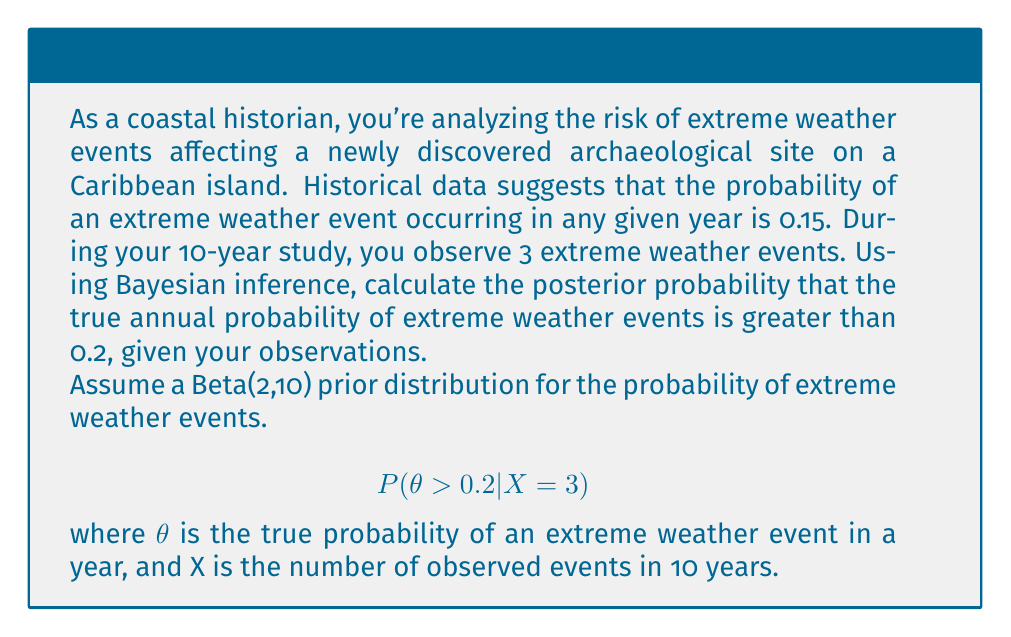What is the answer to this math problem? Let's approach this step-by-step using Bayesian inference:

1) We start with a Beta(2,10) prior distribution for $\theta$. The probability density function (PDF) of this distribution is:

   $$f(\theta) = \frac{\theta^{1}(1-\theta)^{9}}{B(2,10)}$$

2) The likelihood function for observing 3 events in 10 years follows a Binomial distribution:

   $$L(X=3|\theta) = \binom{10}{3}\theta^3(1-\theta)^7$$

3) According to Bayes' theorem, the posterior distribution is proportional to the product of the prior and the likelihood:

   $$f(\theta|X=3) \propto \theta^{1}(1-\theta)^{9} \cdot \theta^3(1-\theta)^7$$
   $$f(\theta|X=3) \propto \theta^4(1-\theta)^{16}$$

4) This is proportional to a Beta(5,17) distribution. The posterior distribution is therefore Beta(5,17).

5) To find $P(\theta > 0.2 | X = 3)$, we need to integrate the posterior distribution from 0.2 to 1:

   $$P(\theta > 0.2 | X = 3) = \int_{0.2}^1 \frac{\theta^4(1-\theta)^{16}}{B(5,17)} d\theta$$

6) This integral doesn't have a simple closed form, so we'll use the cumulative distribution function (CDF) of the Beta distribution:

   $$P(\theta > 0.2 | X = 3) = 1 - \text{CDF}_{\text{Beta}(5,17)}(0.2)$$

7) Using a statistical software or calculator, we can compute this value:

   $$P(\theta > 0.2 | X = 3) \approx 1 - 0.9274 = 0.0726$$

Therefore, the posterior probability that the true annual probability of extreme weather events is greater than 0.2, given the observations, is approximately 0.0726 or 7.26%.
Answer: 0.0726 